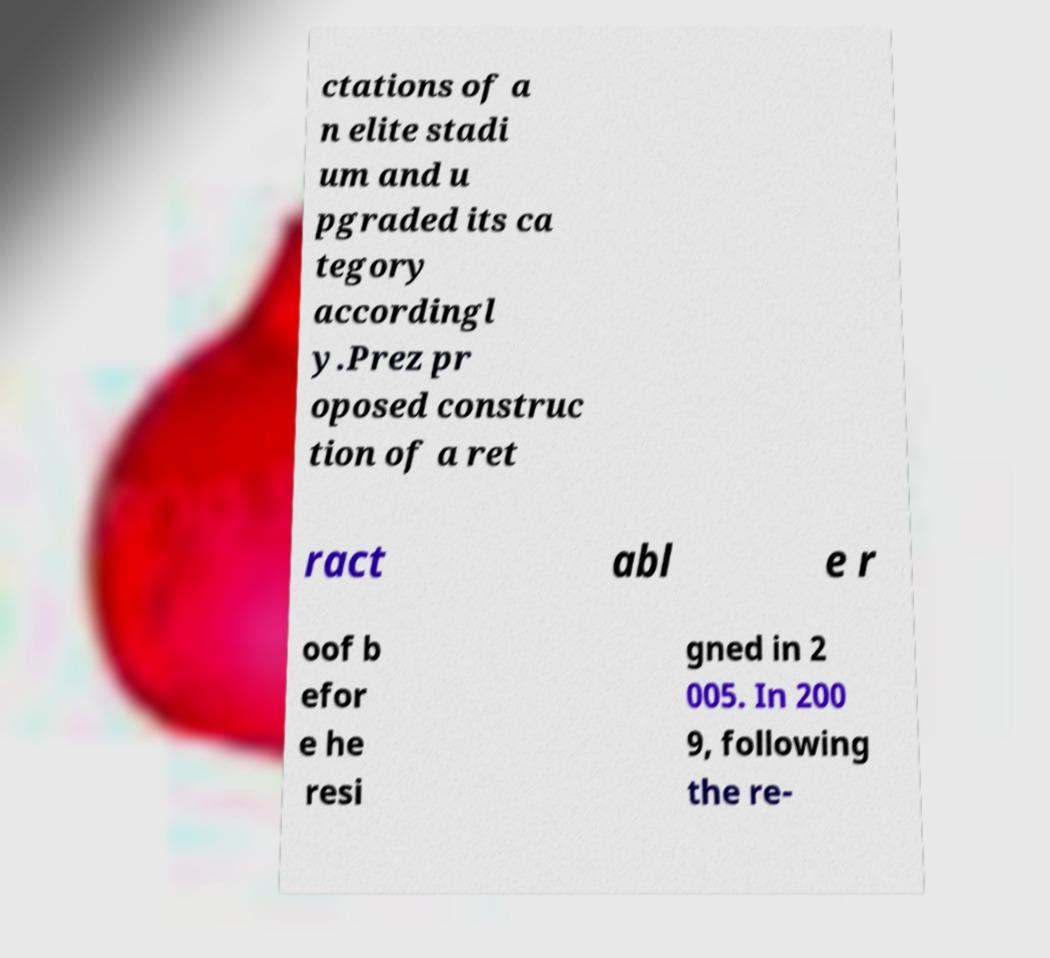I need the written content from this picture converted into text. Can you do that? ctations of a n elite stadi um and u pgraded its ca tegory accordingl y.Prez pr oposed construc tion of a ret ract abl e r oof b efor e he resi gned in 2 005. In 200 9, following the re- 